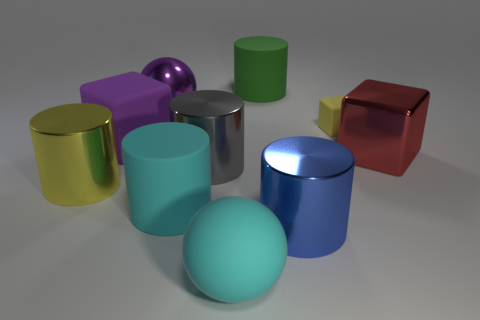Subtract all rubber blocks. How many blocks are left? 1 Subtract all yellow blocks. How many blocks are left? 2 Subtract 1 blocks. How many blocks are left? 2 Subtract all brown cylinders. Subtract all purple cubes. How many cylinders are left? 5 Subtract all blue rubber balls. Subtract all green cylinders. How many objects are left? 9 Add 7 green cylinders. How many green cylinders are left? 8 Add 5 big red cubes. How many big red cubes exist? 6 Subtract 0 green balls. How many objects are left? 10 Subtract all blocks. How many objects are left? 7 